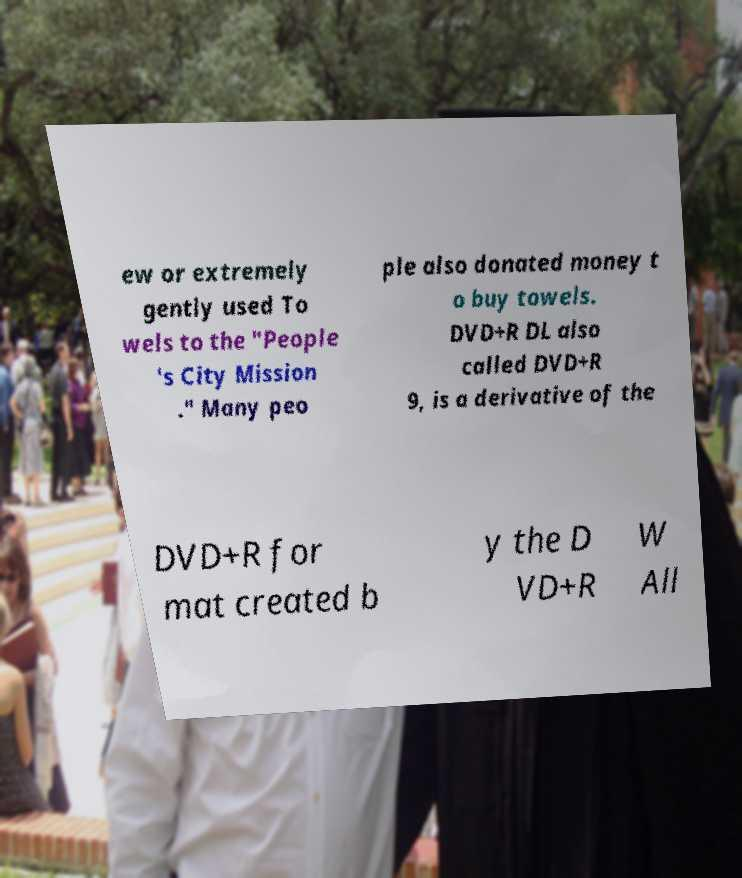I need the written content from this picture converted into text. Can you do that? ew or extremely gently used To wels to the "People 's City Mission ." Many peo ple also donated money t o buy towels. DVD+R DL also called DVD+R 9, is a derivative of the DVD+R for mat created b y the D VD+R W All 